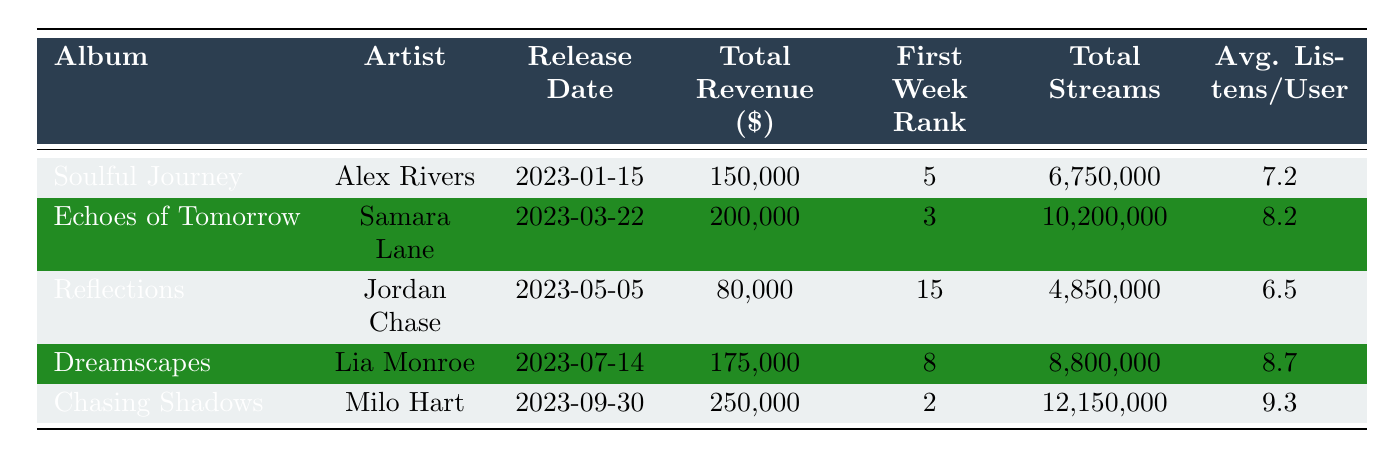What's the total revenue generated by "Chasing Shadows"? The table shows that "Chasing Shadows" has a listed total revenue of 250,000 dollars.
Answer: 250,000 Which album had the highest first week rank? According to the first week rank column, "Chasing Shadows" has the highest rank of 2.
Answer: Chasing Shadows What is the average listens per user for the album "Echoes of Tomorrow"? The table provides an average listens per user of 10.0 for "Echoes of Tomorrow".
Answer: 10.0 How much total revenue did "Reflections" generate compared to "Dreamscapes"? "Reflections" generated 80,000 dollars, while "Dreamscapes" generated 175,000 dollars. The difference in revenue is 175,000 - 80,000 = 95,000 dollars.
Answer: 95,000 Did "Soulful Journey" receive more streams than "Dreamscapes"? "Soulful Journey" received a total of 6,750,000 streams, while "Dreamscapes" got 8,800,000 streams. Therefore, the statement is false.
Answer: No What is the total number of streams for all albums? We sum the total streams of each album: Soulful Journey (6,750,000) + Echoes of Tomorrow (10,200,000) + Reflections (4,850,000) + Dreamscapes (8,800,000) + Chasing Shadows (12,150,000) = 42,750,000 streams total.
Answer: 42,750,000 Which album had the least playlists inclusion on Apple Music? "Reflections" had the least playlists inclusion with a value of 8 on Apple Music, as other albums had higher values.
Answer: Reflections What is the difference in total revenue between the highest and lowest earning albums? The highest revenue is from "Chasing Shadows" with 250,000 dollars and the lowest from "Reflections" with 80,000 dollars. The difference is 250,000 - 80,000 = 170,000 dollars.
Answer: 170,000 Which artist had the most total streams across all their albums? Adding the streams for each artist: Alex Rivers (6,750,000) + Samara Lane (10,200,000) + Jordan Chase (4,850,000) + Lia Monroe (8,800,000) + Milo Hart (12,150,000) gives a total of 42,750,000 streams for Milo Hart.
Answer: Milo Hart How many albums had an average listens per user greater than 8? Checking the average listens per user values, three albums have values greater than 8: "Chasing Shadows" (11.5), "Echoes of Tomorrow" (10.0), and "Dreamscapes" (9.8). Thus, there are three albums.
Answer: 3 Is the first week rank of "Soulful Journey" better than that of "Reflections"? The first week rank of "Soulful Journey" is 5 and "Reflections" is 15, indicating that "Soulful Journey" had a better rank (lower number is better).
Answer: Yes 